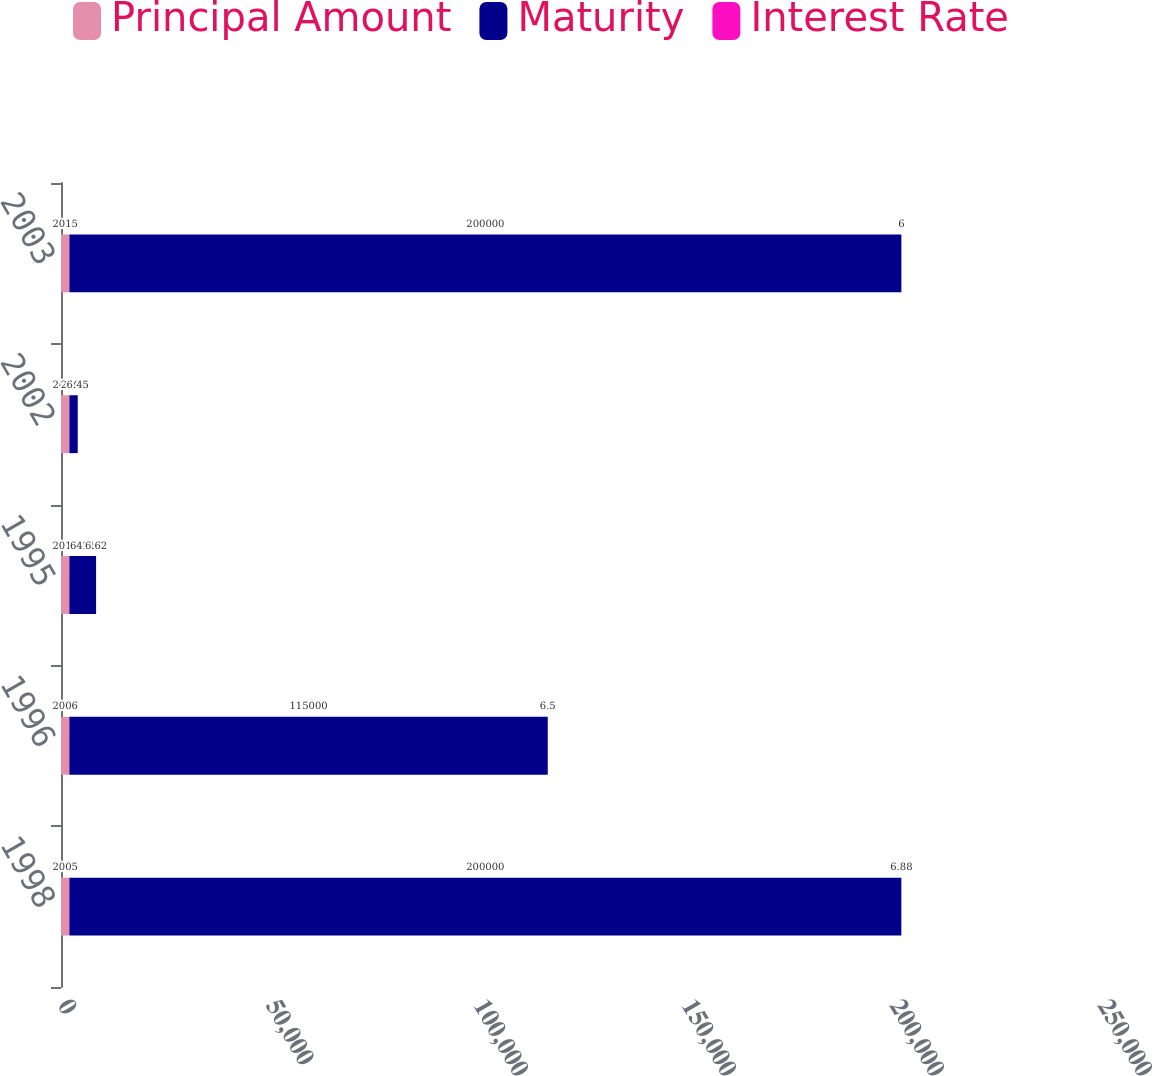Convert chart to OTSL. <chart><loc_0><loc_0><loc_500><loc_500><stacked_bar_chart><ecel><fcel>1998<fcel>1996<fcel>1995<fcel>2002<fcel>2003<nl><fcel>Principal Amount<fcel>2005<fcel>2006<fcel>2010<fcel>2012<fcel>2015<nl><fcel>Maturity<fcel>200000<fcel>115000<fcel>6421<fcel>2008<fcel>200000<nl><fcel>Interest Rate<fcel>6.88<fcel>6.5<fcel>6.62<fcel>6.45<fcel>6<nl></chart> 